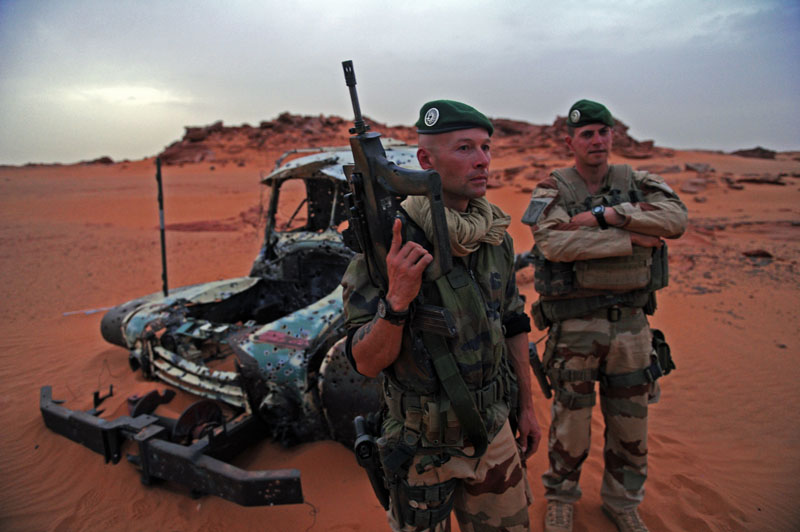Can you describe the emotional state of the soldiers in this environment? The soldiers appear to be in a state of alertness and readiness. The serious expressions on their faces and their posture suggest they are fully aware of the possible dangers in such an inhospitable environment. The harsh, desolate surroundings likely contribute to a sense of vigilance and determination to stay focused and prepared for any contingencies. What might the soldiers' strategy be for surviving in this harsh terrain? To survive in this desert terrain, the soldiers would need to adopt several strategies. Staying hydrated is crucial, so they would prioritize carrying and rationing water. They would need to be cautious about heat exposure, possibly resting during the hottest parts of the day and traveling during cooler periods. Navigation would be key, requiring the use of maps, GPS devices, and perhaps even the stars at night to avoid getting lost. Regular maintenance of their equipment would be important to prevent malfunctions due to sand. Establishing a base with shade and protection against the elements could also be part of their survival strategy. Additionally, maintaining communication with their base or other units would be critical for receiving updates and support. 